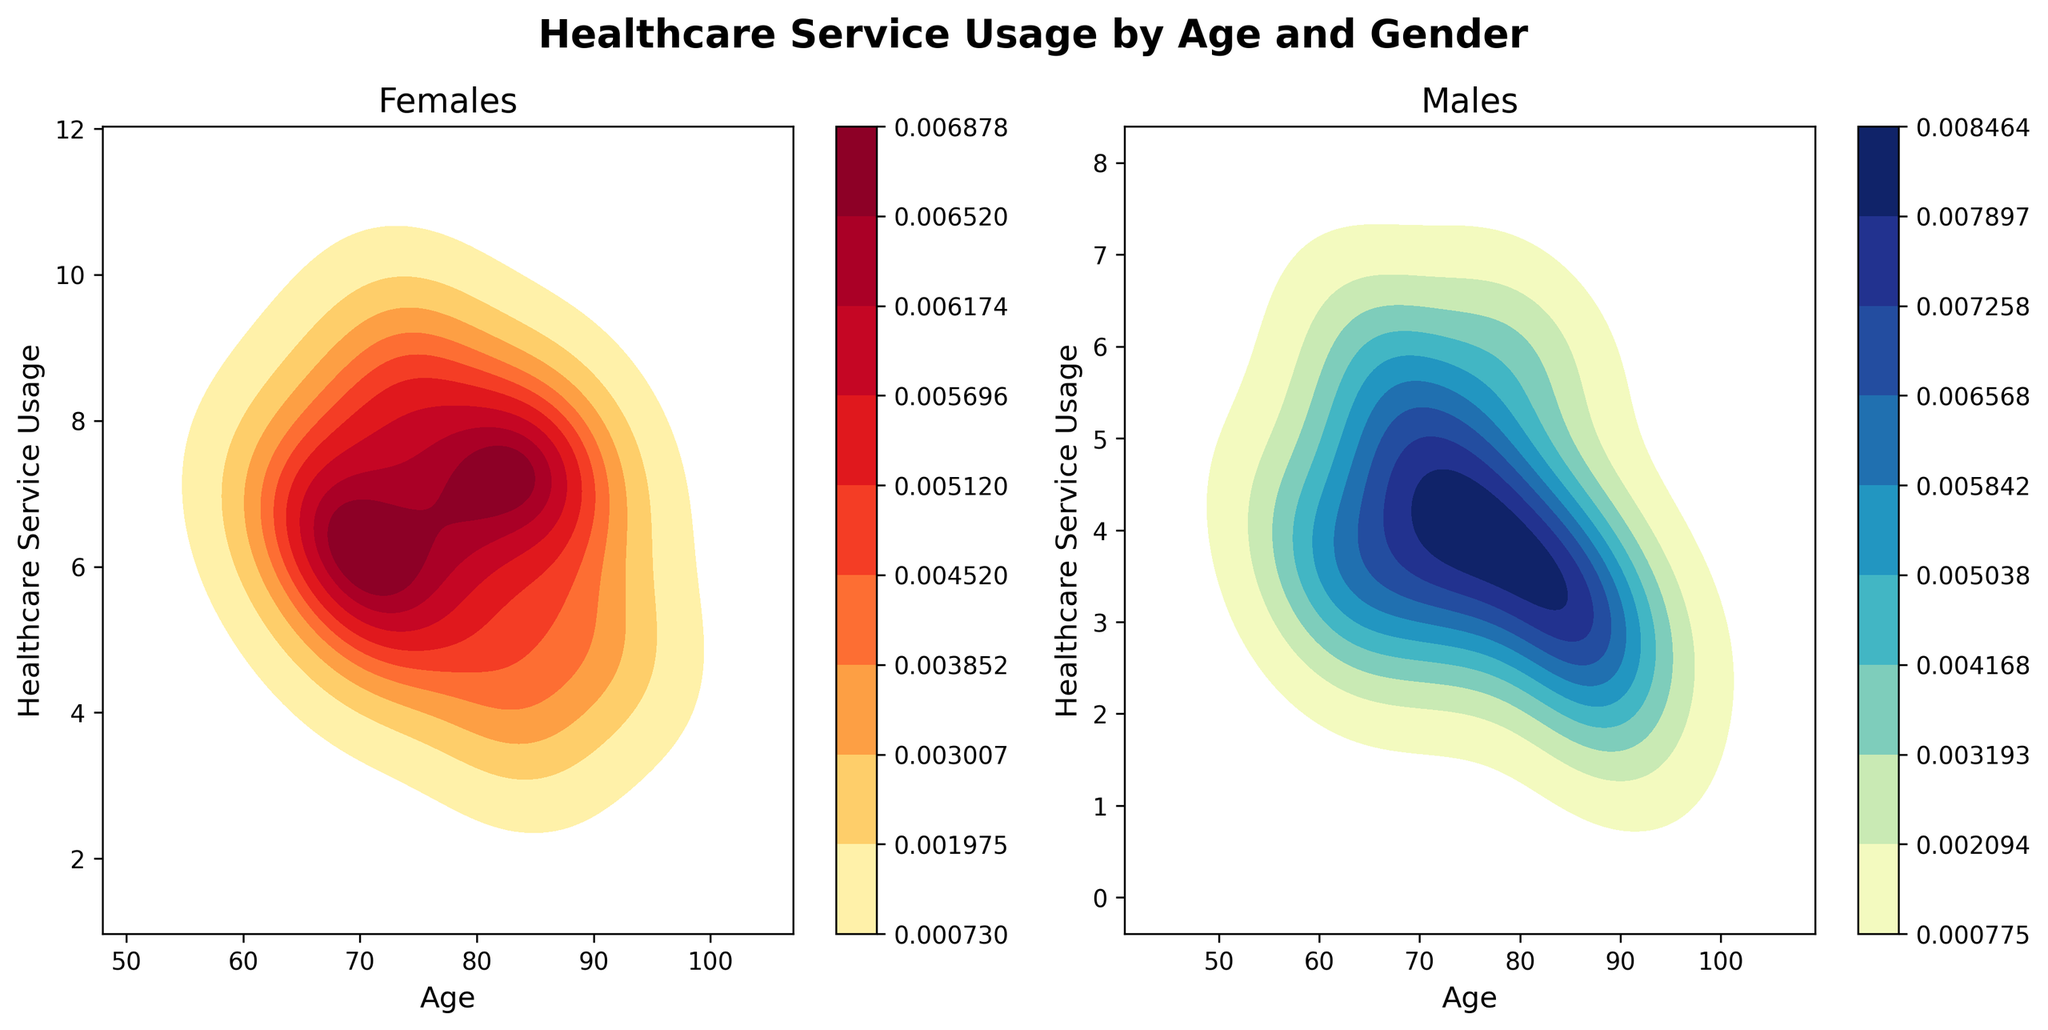What is the title of the figure? The title is generally presented at the top center of the figure. In this case, it's visible at the top as "Healthcare Service Usage by Age and Gender".
Answer: "Healthcare Service Usage by Age and Gender" What's the difference in the axis labels between the two subplots? Each subplot has its axis labels. The left subplot for Females has "Age" on the x-axis and "Healthcare Service Usage" on the y-axis, and the right subplot for Males has the same labels on both axes.
Answer: They are the same in both subplots What color scheme is used for the Female density plot? The Female density plot uses a color gradient that moves from lighter to darker shades, usually indicative in yellow-red hues.
Answer: Yellow-Red What age group among Females shows the highest healthcare service usage? By observing the height and density in the Female density plot, the age group around 75 appears to have the highest usage.
Answer: Around age 75 Which gender has a generally higher healthcare service usage? Comparing the peaks of each density plot, the Female subplot has higher peaks indicating a generally higher usage compared to males.
Answer: Female How do the peaks in healthcare service usage differ between Males and Females? The peaks are examined by looking at the highest density points. Females tend to have higher peaks in healthcare usage around age 75, while Males have flatter peaks dispersed around ages 65 and 80.
Answer: Females around age 75, Males around ages 65 and 80 On the Male density plot, which age group shows the lowest healthcare service usage? The least dense areas in the Male density plot represent the lowest healthcare service usage, which appears to be around ages 88-90.
Answer: Around ages 88-90 What's the overall trend of healthcare service usage with age for Females? By following the density changes in the Female plot, the healthcare usage tends to slightly increase with age but then experiences fluctuations around specific ages.
Answer: Slight increase with fluctuations Which gender shows more variance in healthcare service usage across different ages? Variance can be inferred from how widespread the density regions are. The Female plot appears to have more variance as the densities change more significantly compared to the Male plot.
Answer: Female In the Female density plot, which age range has significant density and usage ambiguity? There are notable ambiguous densities (overlapping lighter shades) in the age range around 70 to 80 years.
Answer: Around 70 to 80 years 